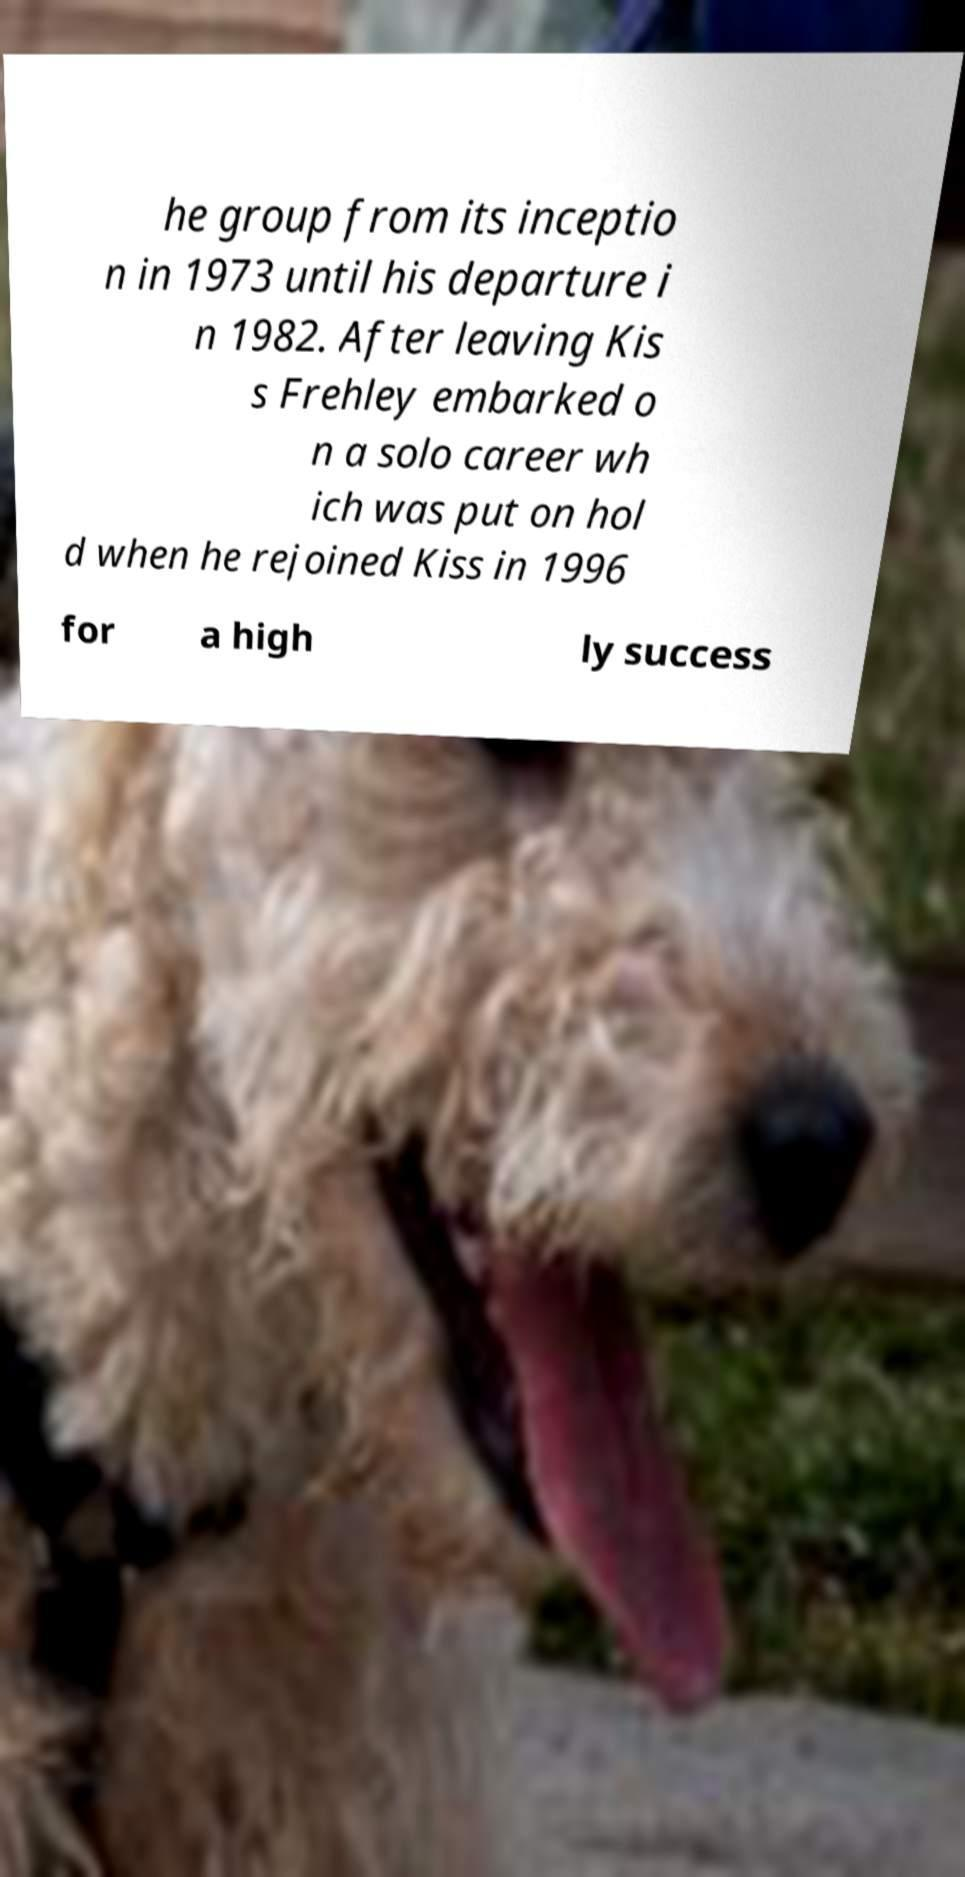There's text embedded in this image that I need extracted. Can you transcribe it verbatim? he group from its inceptio n in 1973 until his departure i n 1982. After leaving Kis s Frehley embarked o n a solo career wh ich was put on hol d when he rejoined Kiss in 1996 for a high ly success 